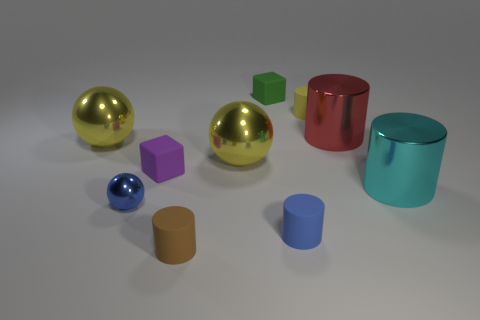Subtract all blue cylinders. How many cylinders are left? 4 Subtract all tiny blue matte cylinders. How many cylinders are left? 4 Subtract all gray cylinders. Subtract all yellow spheres. How many cylinders are left? 5 Subtract all balls. How many objects are left? 7 Add 2 cyan things. How many cyan things exist? 3 Subtract 0 cyan spheres. How many objects are left? 10 Subtract all tiny green rubber things. Subtract all tiny blue matte things. How many objects are left? 8 Add 1 tiny matte cylinders. How many tiny matte cylinders are left? 4 